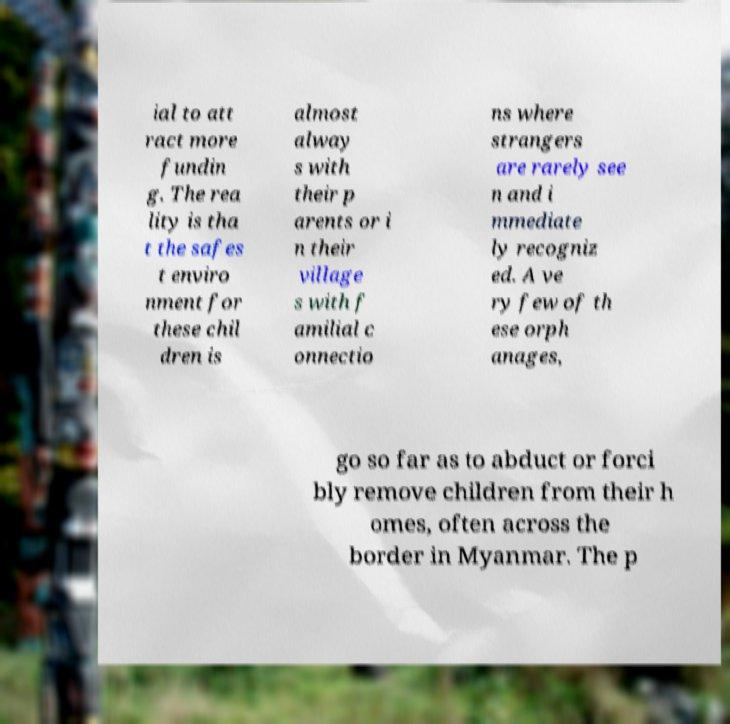Could you assist in decoding the text presented in this image and type it out clearly? ial to att ract more fundin g. The rea lity is tha t the safes t enviro nment for these chil dren is almost alway s with their p arents or i n their village s with f amilial c onnectio ns where strangers are rarely see n and i mmediate ly recogniz ed. A ve ry few of th ese orph anages, go so far as to abduct or forci bly remove children from their h omes, often across the border in Myanmar. The p 